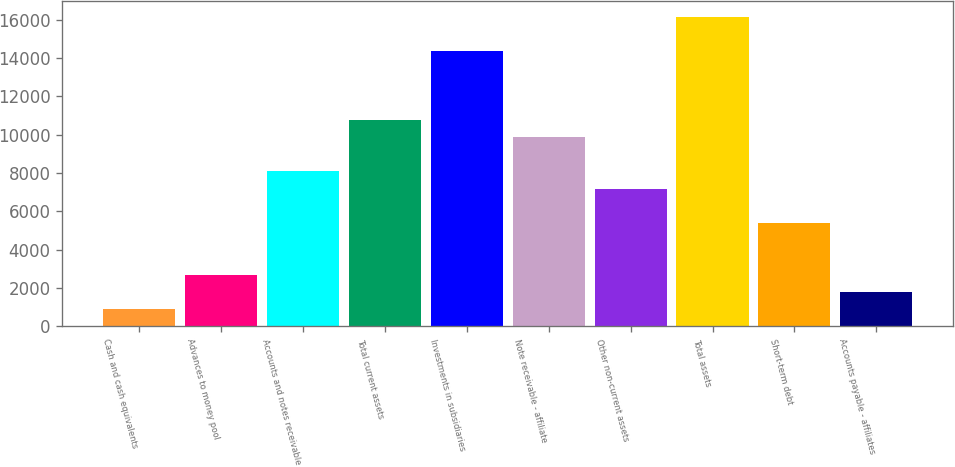Convert chart. <chart><loc_0><loc_0><loc_500><loc_500><bar_chart><fcel>Cash and cash equivalents<fcel>Advances to money pool<fcel>Accounts and notes receivable<fcel>Total current assets<fcel>Investments in subsidiaries<fcel>Note receivable - affiliate<fcel>Other non-current assets<fcel>Total assets<fcel>Short-term debt<fcel>Accounts payable - affiliates<nl><fcel>900.2<fcel>2696.6<fcel>8085.8<fcel>10780.4<fcel>14373.2<fcel>9882.2<fcel>7187.6<fcel>16169.6<fcel>5391.2<fcel>1798.4<nl></chart> 